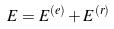Convert formula to latex. <formula><loc_0><loc_0><loc_500><loc_500>E = E ^ { ( e ) } + E ^ { ( r ) }</formula> 